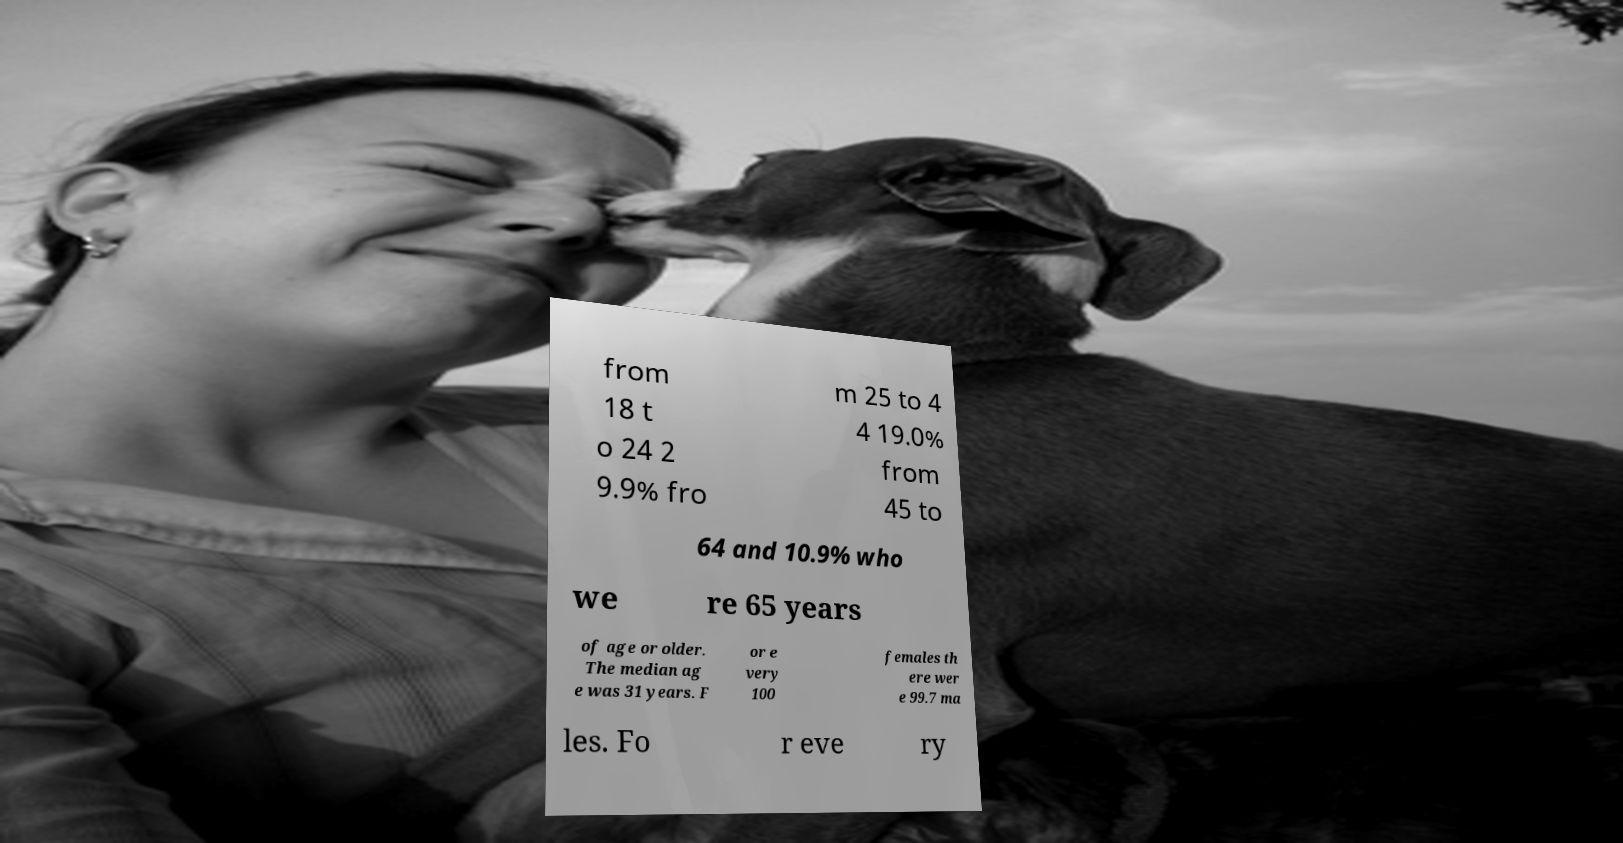For documentation purposes, I need the text within this image transcribed. Could you provide that? from 18 t o 24 2 9.9% fro m 25 to 4 4 19.0% from 45 to 64 and 10.9% who we re 65 years of age or older. The median ag e was 31 years. F or e very 100 females th ere wer e 99.7 ma les. Fo r eve ry 